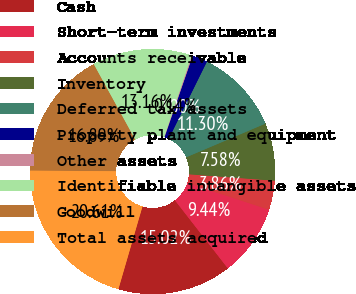Convert chart to OTSL. <chart><loc_0><loc_0><loc_500><loc_500><pie_chart><fcel>Cash<fcel>Short-term investments<fcel>Accounts receivable<fcel>Inventory<fcel>Deferred tax assets<fcel>Property plant and equipment<fcel>Other assets<fcel>Identifiable intangible assets<fcel>Goodwill<fcel>Total assets acquired<nl><fcel>15.02%<fcel>9.44%<fcel>3.86%<fcel>7.58%<fcel>11.3%<fcel>2.0%<fcel>0.14%<fcel>13.16%<fcel>16.89%<fcel>20.61%<nl></chart> 